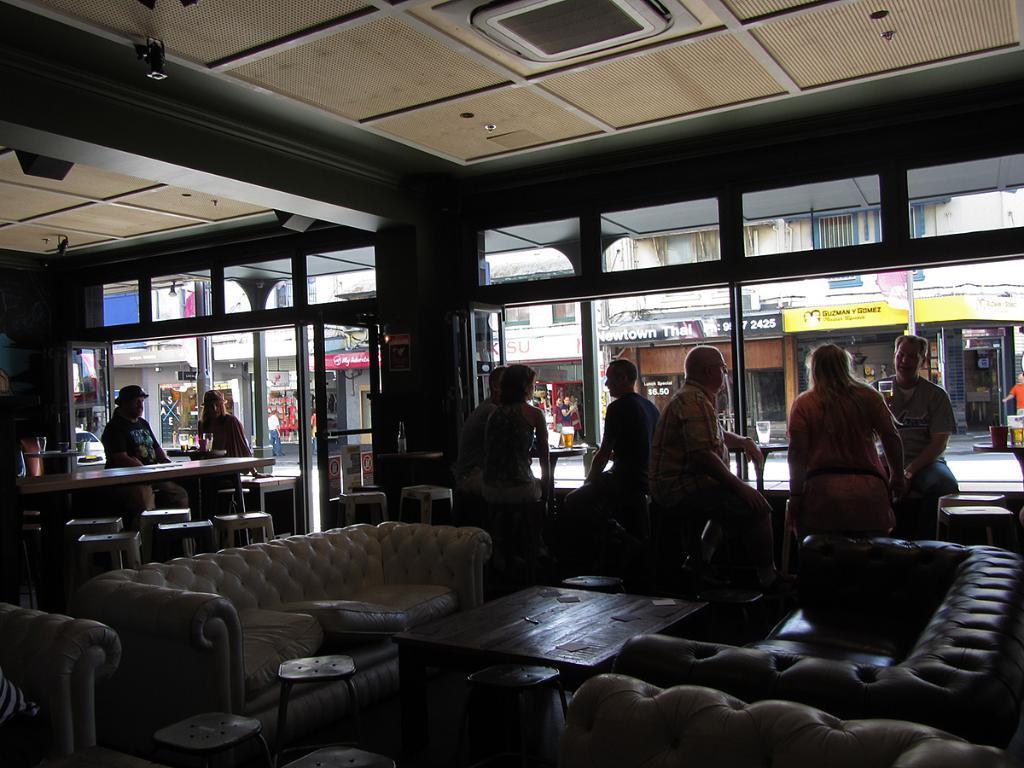Please provide a concise description of this image. As we can see in the image there are few people here and there, sofa, table, chairs and buildings. 